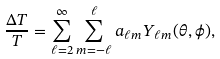Convert formula to latex. <formula><loc_0><loc_0><loc_500><loc_500>\frac { \Delta T } { T } = \sum _ { \ell = 2 } ^ { \infty } \sum _ { m = - \ell } ^ { \ell } a _ { \ell m } Y _ { \ell m } ( \theta , \phi ) ,</formula> 